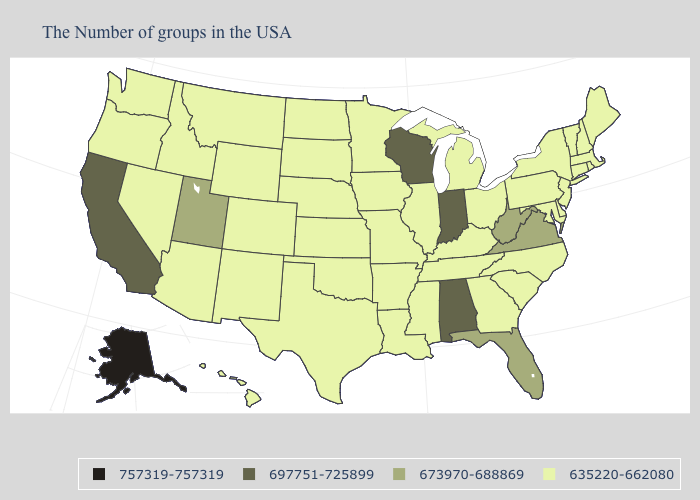Name the states that have a value in the range 673970-688869?
Answer briefly. Virginia, West Virginia, Florida, Utah. Name the states that have a value in the range 757319-757319?
Concise answer only. Alaska. Name the states that have a value in the range 697751-725899?
Be succinct. Indiana, Alabama, Wisconsin, California. Name the states that have a value in the range 635220-662080?
Answer briefly. Maine, Massachusetts, Rhode Island, New Hampshire, Vermont, Connecticut, New York, New Jersey, Delaware, Maryland, Pennsylvania, North Carolina, South Carolina, Ohio, Georgia, Michigan, Kentucky, Tennessee, Illinois, Mississippi, Louisiana, Missouri, Arkansas, Minnesota, Iowa, Kansas, Nebraska, Oklahoma, Texas, South Dakota, North Dakota, Wyoming, Colorado, New Mexico, Montana, Arizona, Idaho, Nevada, Washington, Oregon, Hawaii. What is the lowest value in the USA?
Keep it brief. 635220-662080. Name the states that have a value in the range 673970-688869?
Write a very short answer. Virginia, West Virginia, Florida, Utah. What is the value of South Carolina?
Concise answer only. 635220-662080. What is the value of Connecticut?
Quick response, please. 635220-662080. Name the states that have a value in the range 757319-757319?
Concise answer only. Alaska. Does Indiana have the highest value in the MidWest?
Answer briefly. Yes. Name the states that have a value in the range 673970-688869?
Answer briefly. Virginia, West Virginia, Florida, Utah. Does Colorado have the same value as South Carolina?
Answer briefly. Yes. What is the value of Alabama?
Answer briefly. 697751-725899. 